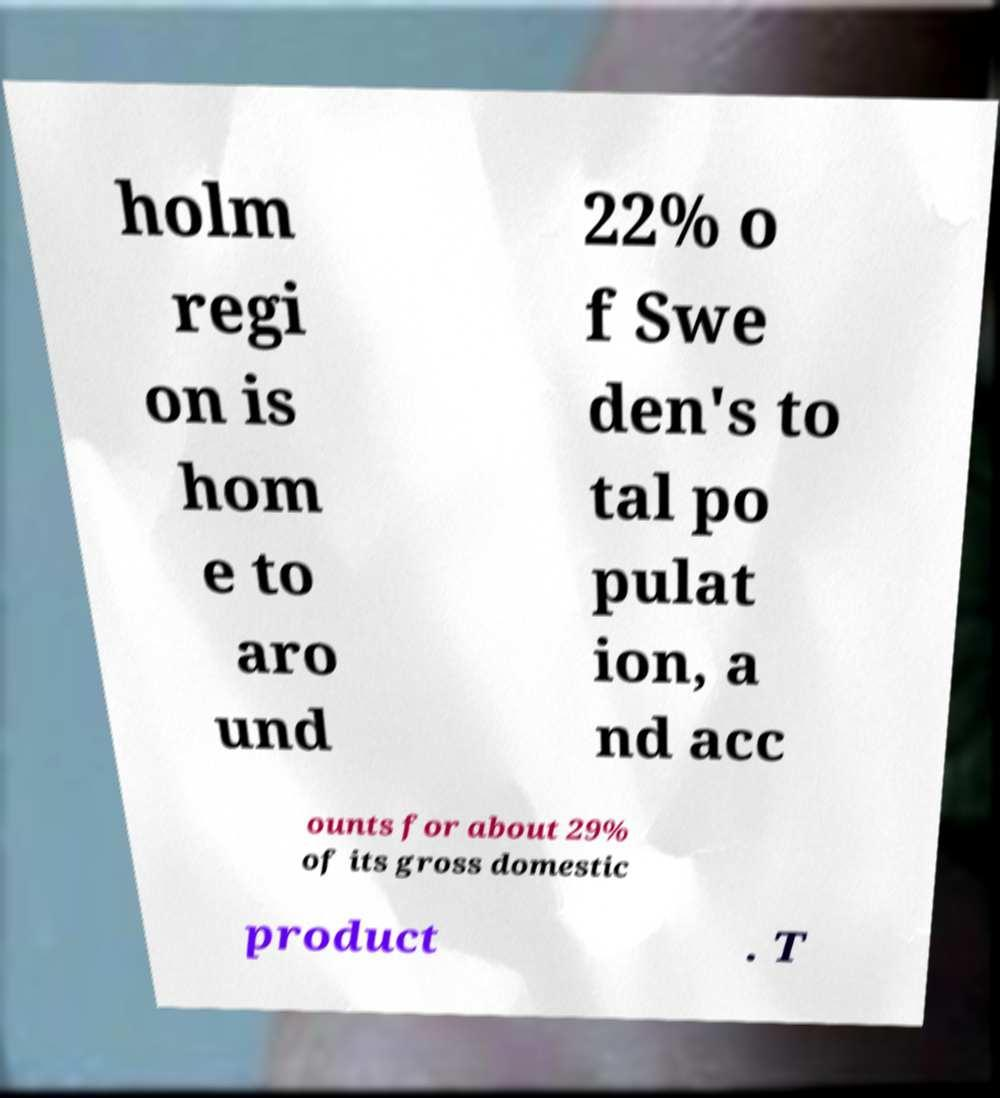I need the written content from this picture converted into text. Can you do that? holm regi on is hom e to aro und 22% o f Swe den's to tal po pulat ion, a nd acc ounts for about 29% of its gross domestic product . T 